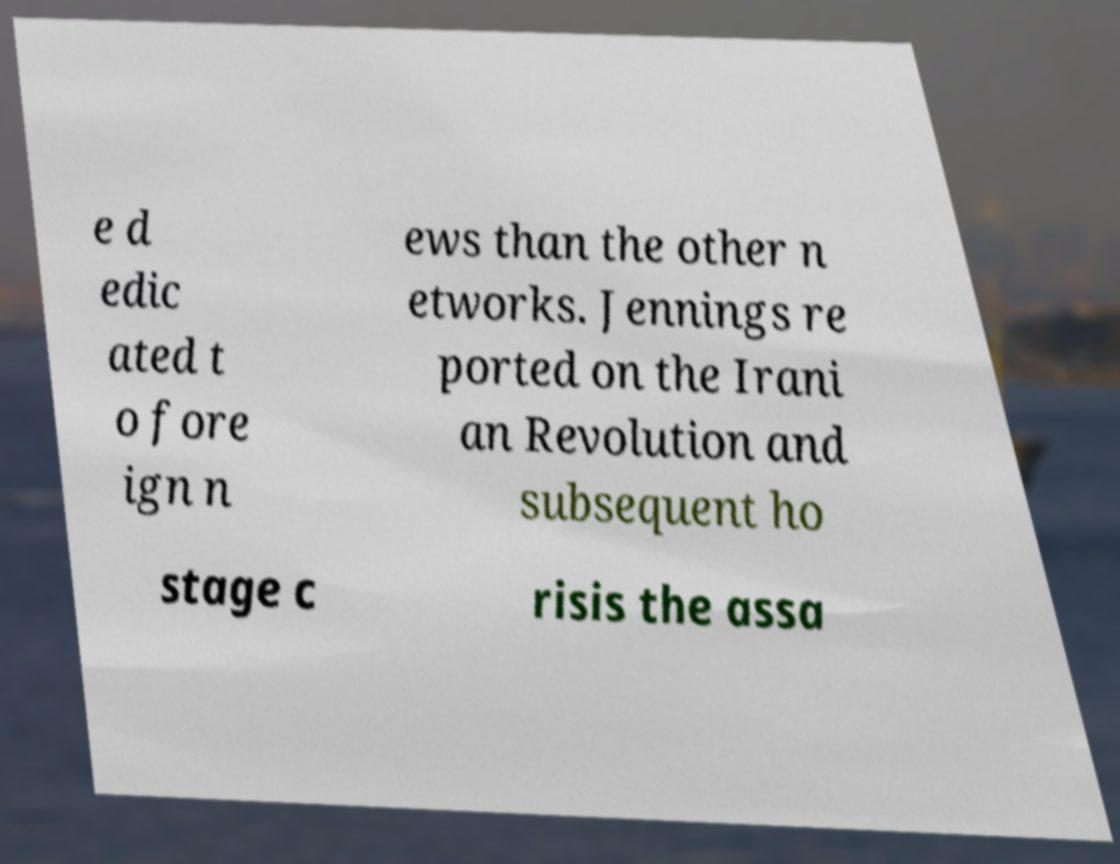Could you assist in decoding the text presented in this image and type it out clearly? e d edic ated t o fore ign n ews than the other n etworks. Jennings re ported on the Irani an Revolution and subsequent ho stage c risis the assa 